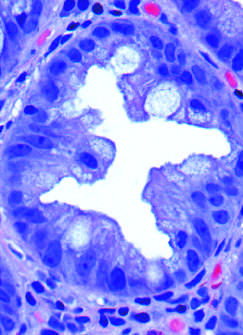re previous episodes of rheumatic valvulitis cut in cross-section?
Answer the question using a single word or phrase. No 